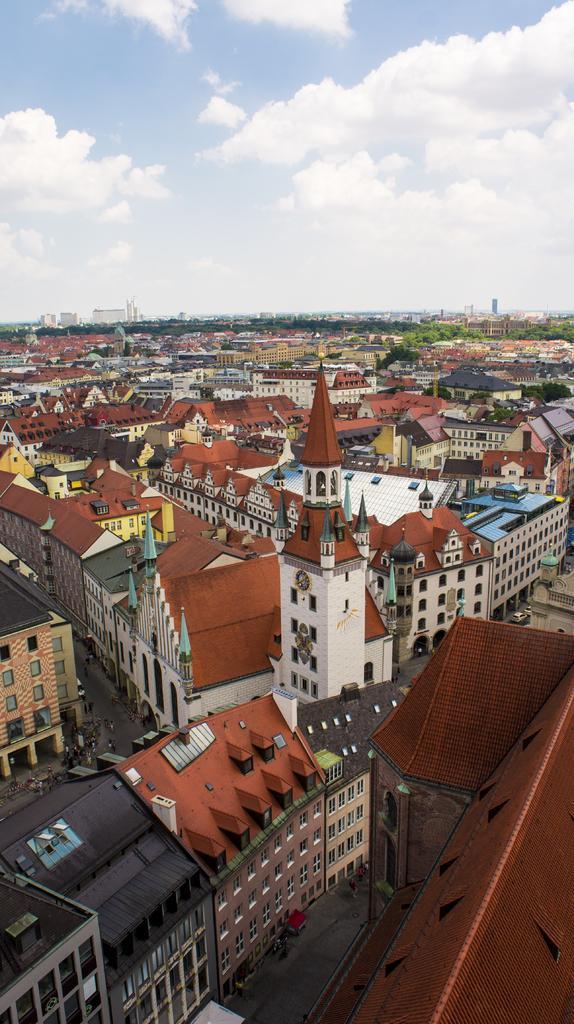Can you describe this image briefly? In this image we can see a group of buildings with windows, a tower with a clock and the roads. On the backside we can see some trees and the sky which looks cloudy. 